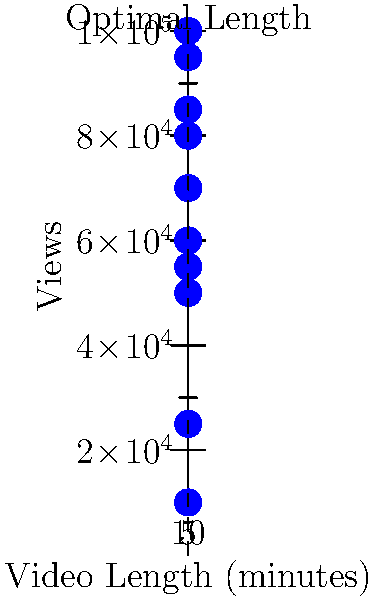Your favorite YouTuber wants to maximize their video engagement. Based on the scatter plot showing video length vs. views, what's the optimal video length for maximum views? How many views can they expect at this length? To find the optimal video length for maximum views, we need to analyze the scatter plot:

1. Observe the trend: As video length increases, views initially increase, then decrease.
2. Identify the peak: The highest point on the graph represents maximum views.
3. Find the corresponding x-value: The x-value (video length) at the peak is 5 minutes.
4. Determine the y-value: At 5 minutes, the corresponding y-value (views) is 100,000.

Therefore, the optimal video length is 5 minutes, and the expected number of views at this length is 100,000.

This aligns with typical YouTube analytics, where shorter videos (3-7 minutes) often perform well due to audience attention spans and platform algorithms.
Answer: 5 minutes, 100,000 views 